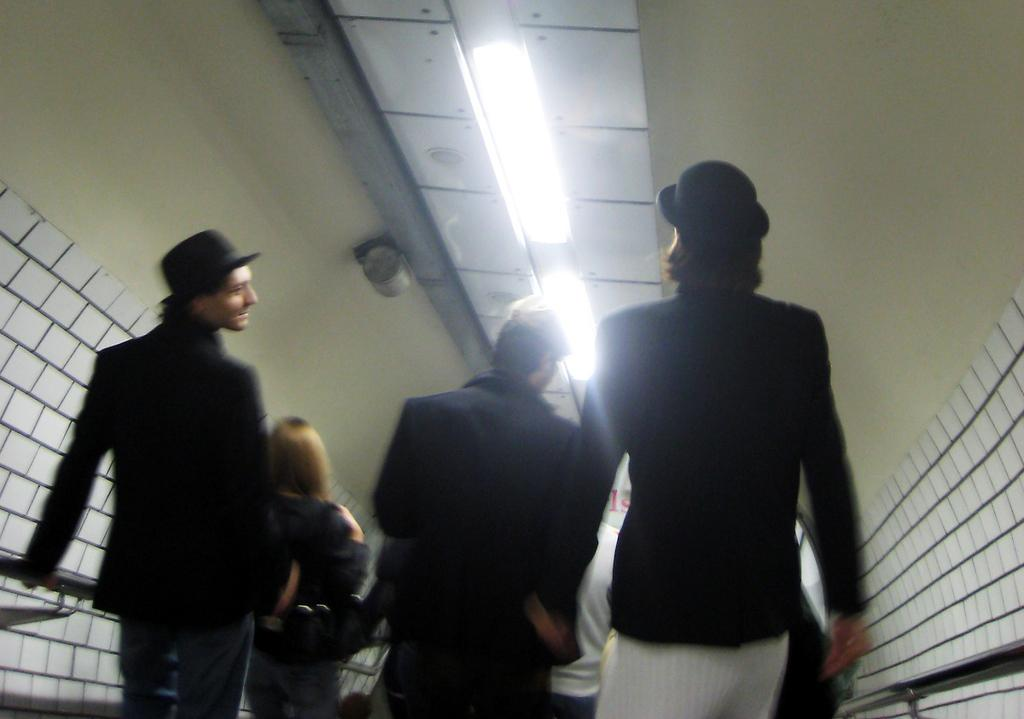What is the main subject in the center of the image? There are people in the center of the image. What can be seen at the top of the image? There is a ceiling with lights at the top of the image. What is located to the right side of the image? There is: There is a wall to the right side of the image. What feature is present that might be used for support or safety? There is: There is a railing present. Reasoning: Let' Let's think step by step in order to produce the conversation. We start by identifying the main subject in the image, which is the people in the center. Then, we expand the conversation to include other elements of the image, such as the ceiling with lights, the wall to the right, and the railing. Each question is designed to elicit a specific detail about the image that is known from the provided facts. Absurd Question/Answer: How high is the kite flying in the image? There is no kite present in the image, so it is not possible to determine the height at which a kite might be flying. How many giraffes can be seen in the image? There are no giraffes present in the image. 